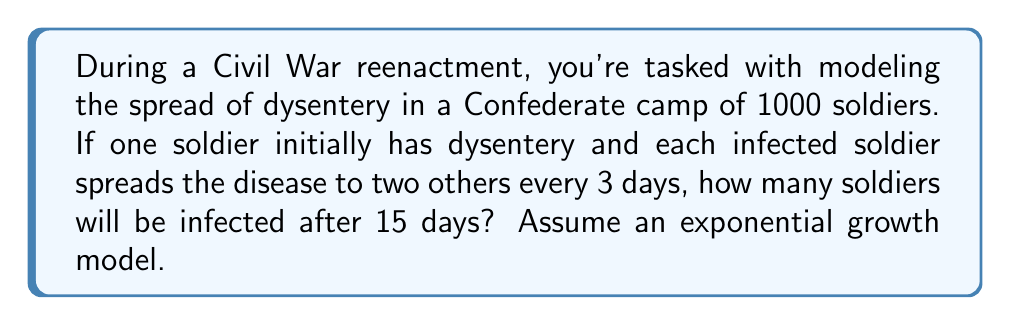Teach me how to tackle this problem. To solve this problem, we'll use the exponential growth model:

$$N(t) = N_0 \cdot e^{rt}$$

Where:
$N(t)$ is the number of infected soldiers at time $t$
$N_0$ is the initial number of infected soldiers
$e$ is Euler's number
$r$ is the growth rate
$t$ is the time in days

First, we need to calculate the growth rate $r$:

1) Every 3 days, the number of infected soldiers triples (1 soldier infects 2 others).
2) This means that in 3 days, $N(3) = 3N_0$

We can use this information to find $r$:

$$3 = e^{3r}$$

Taking the natural log of both sides:

$$\ln(3) = 3r$$

$$r = \frac{\ln(3)}{3} \approx 0.3662$$

Now we can use the exponential growth formula:

$$N(15) = 1 \cdot e^{0.3662 \cdot 15}$$

$$N(15) = e^{5.493} \approx 243.2$$

Since we can't have a fractional number of infected soldiers, we round down to the nearest whole number.
Answer: 243 soldiers will be infected after 15 days. 